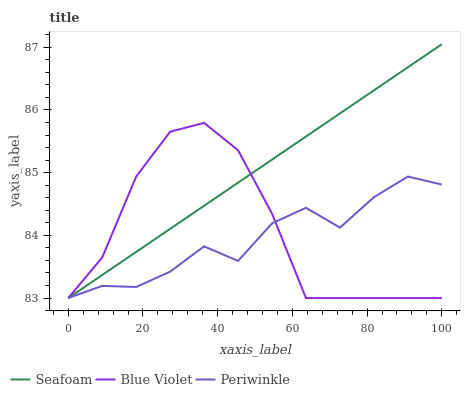Does Blue Violet have the minimum area under the curve?
Answer yes or no. No. Does Blue Violet have the maximum area under the curve?
Answer yes or no. No. Is Blue Violet the smoothest?
Answer yes or no. No. Is Seafoam the roughest?
Answer yes or no. No. Does Blue Violet have the highest value?
Answer yes or no. No. 